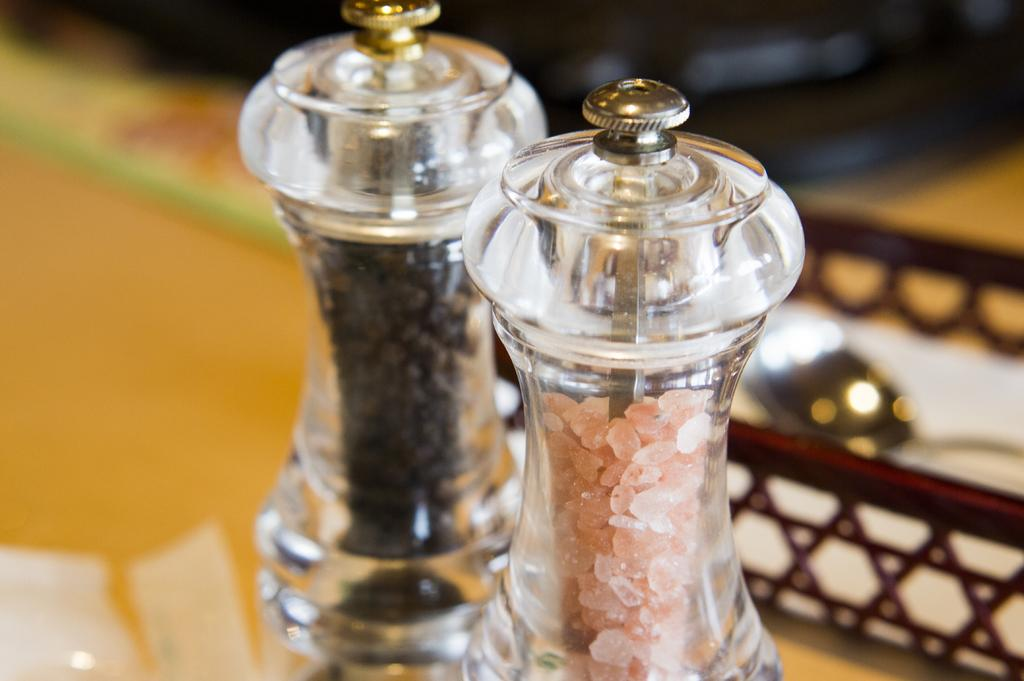How many glass bottles are visible in the image? There are two glass bottles in the image. What are the glass bottles placed on? The glass bottles are on an object. What can be seen on the right side of the object? There is a spoon on the right side of the object. Can you describe the background of the image? The background of the image is blurred. What type of reaction can be seen happening in the cave in the image? There is no cave present in the image, so no reaction can be observed. 